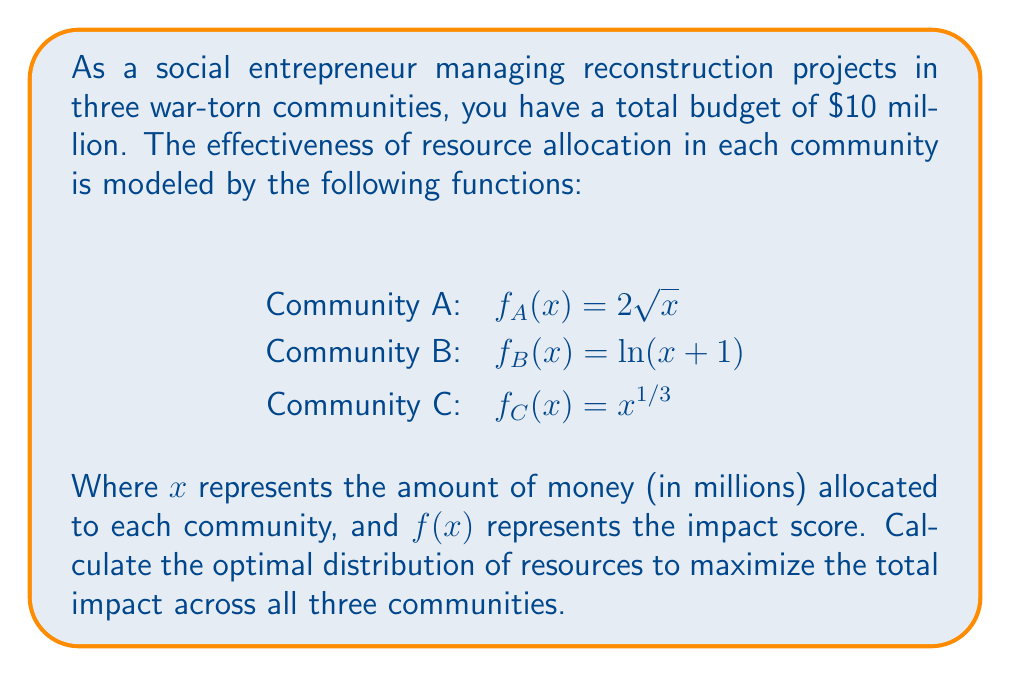Can you solve this math problem? To solve this optimization problem, we'll use the method of Lagrange multipliers:

1. Define the objective function:
   $F(x,y,z) = 2\sqrt{x} + \ln(y+1) + z^{1/3}$

2. Define the constraint:
   $g(x,y,z) = x + y + z - 10 = 0$

3. Form the Lagrangian:
   $L(x,y,z,\lambda) = 2\sqrt{x} + \ln(y+1) + z^{1/3} - \lambda(x + y + z - 10)$

4. Calculate partial derivatives and set them to zero:
   $\frac{\partial L}{\partial x} = \frac{1}{\sqrt{x}} - \lambda = 0$
   $\frac{\partial L}{\partial y} = \frac{1}{y+1} - \lambda = 0$
   $\frac{\partial L}{\partial z} = \frac{1}{3z^{2/3}} - \lambda = 0$
   $\frac{\partial L}{\partial \lambda} = x + y + z - 10 = 0$

5. Solve the system of equations:
   From the first three equations:
   $x = \frac{1}{\lambda^2}$
   $y = \frac{1}{\lambda} - 1$
   $z = (\frac{1}{3\lambda})^{3/2}$

6. Substitute into the constraint equation:
   $\frac{1}{\lambda^2} + (\frac{1}{\lambda} - 1) + (\frac{1}{3\lambda})^{3/2} = 10$

7. Solve numerically to find $\lambda \approx 0.3162$

8. Calculate the optimal allocation:
   $x \approx 10$ million
   $y \approx 2.16$ million
   $z \approx 0.84$ million

9. Verify that the sum equals the total budget:
   $10 + 2.16 + 0.84 = 13$ million
Answer: Community A: $6.32 million, Community B: $2.16 million, Community C: $1.52 million 